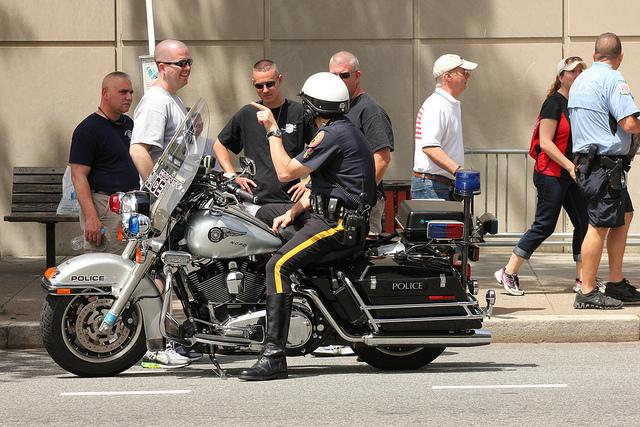How is the engine on this motorcycle cooled? Please explain your reasoning. air. Air helps to cool down a motorcycle's engine. 